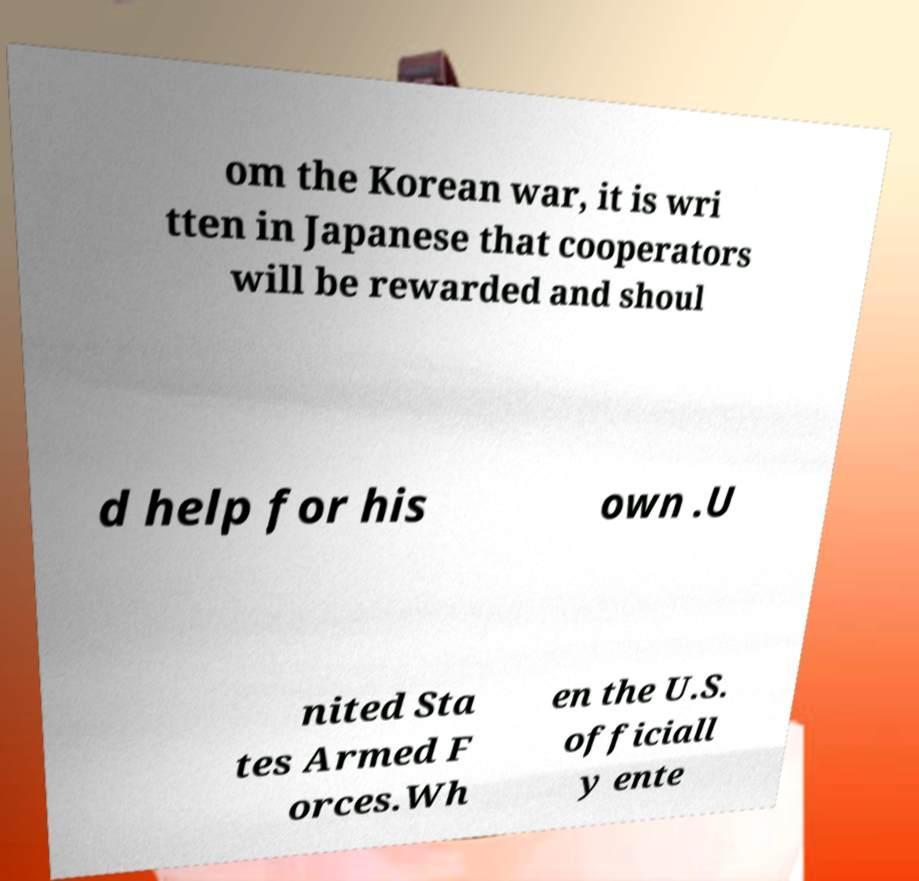I need the written content from this picture converted into text. Can you do that? om the Korean war, it is wri tten in Japanese that cooperators will be rewarded and shoul d help for his own .U nited Sta tes Armed F orces.Wh en the U.S. officiall y ente 